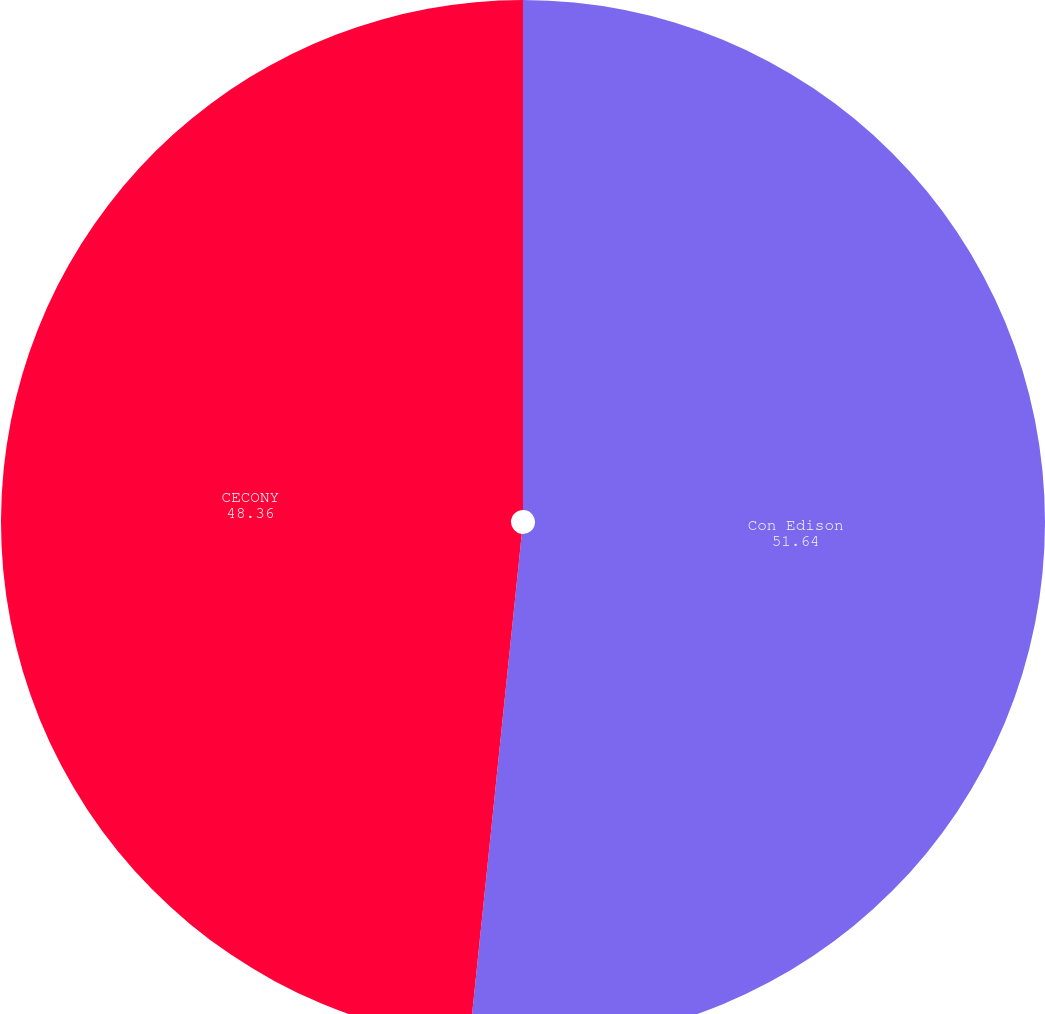Convert chart. <chart><loc_0><loc_0><loc_500><loc_500><pie_chart><fcel>Con Edison<fcel>CECONY<nl><fcel>51.64%<fcel>48.36%<nl></chart> 